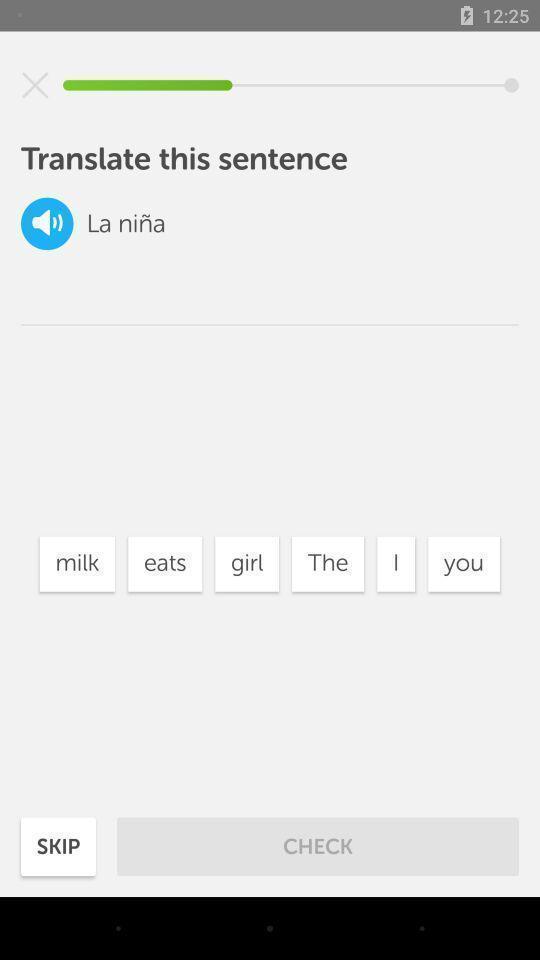Describe this image in words. Page with the language translation application. 